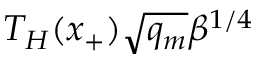<formula> <loc_0><loc_0><loc_500><loc_500>T _ { H } ( x _ { + } ) \sqrt { q _ { m } } \beta ^ { 1 / 4 }</formula> 